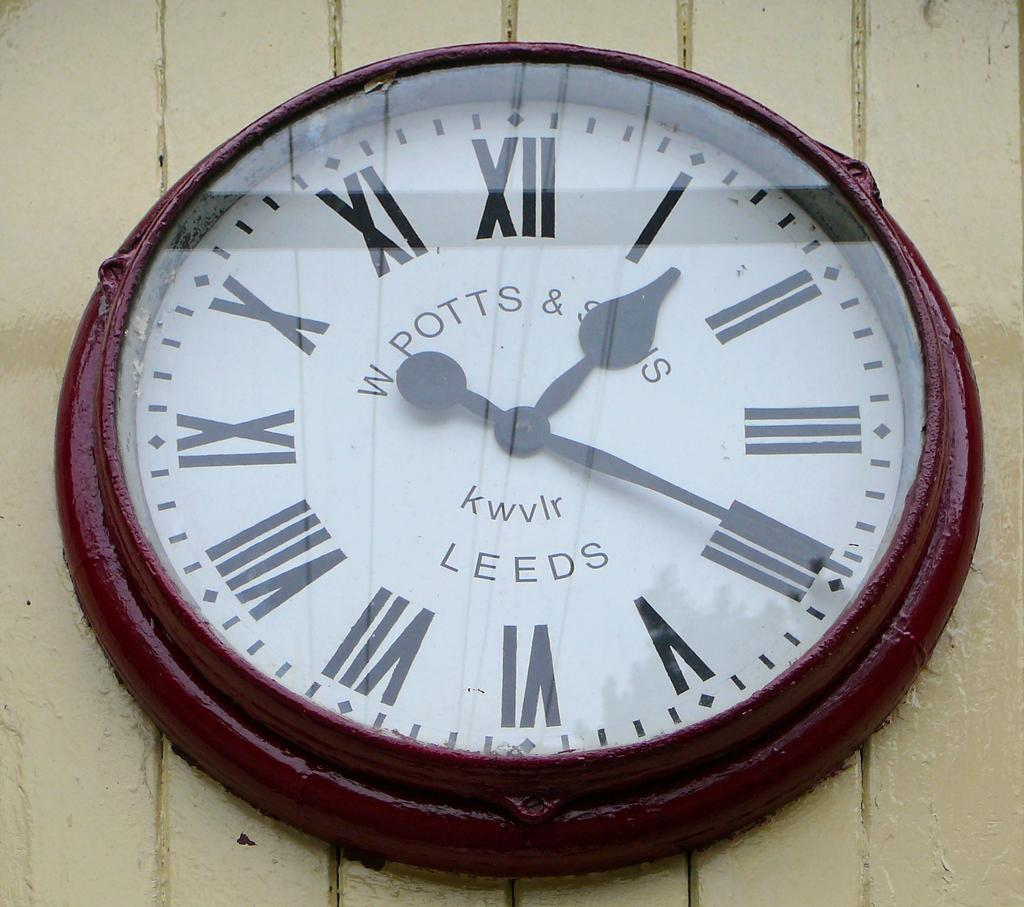<image>
Render a clear and concise summary of the photo. A red clock with a white face that says W POTTS & SONS 